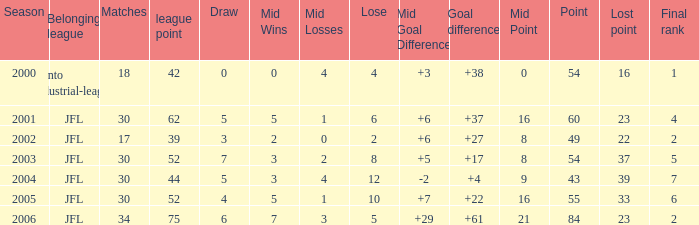Write the full table. {'header': ['Season', 'Belonging league', 'Matches', 'league point', 'Draw', 'Mid Wins', 'Mid Losses', 'Lose', 'Mid Goal Difference', 'Goal difference', 'Mid Point', 'Point', 'Lost point', 'Final rank'], 'rows': [['2000', 'Kanto industrial-league', '18', '42', '0', '0', '4', '4', '+3', '+38', '0', '54', '16', '1'], ['2001', 'JFL', '30', '62', '5', '5', '1', '6', '+6', '+37', '16', '60', '23', '4'], ['2002', 'JFL', '17', '39', '3', '2', '0', '2', '+6', '+27', '8', '49', '22', '2'], ['2003', 'JFL', '30', '52', '7', '3', '2', '8', '+5', '+17', '8', '54', '37', '5'], ['2004', 'JFL', '30', '44', '5', '3', '4', '12', '-2', '+4', '9', '43', '39', '7'], ['2005', 'JFL', '30', '52', '4', '5', '1', '10', '+7', '+22', '16', '55', '33', '6'], ['2006', 'JFL', '34', '75', '6', '7', '3', '5', '+29', '+61', '21', '84', '23', '2']]} Inform me of the top matches for point 43 and ending rank below None. 